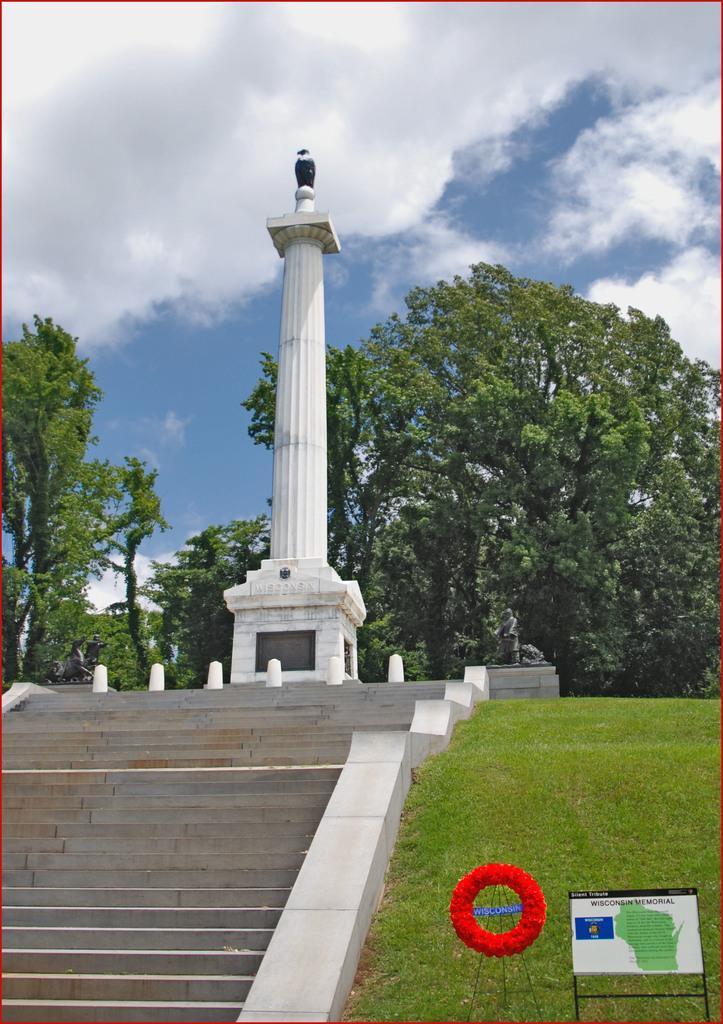Can you describe this image briefly? On the left side there is the staircase and in the middle there is a pillar in white color, at the back side there are trees. At the top it is the cloudy sky. 